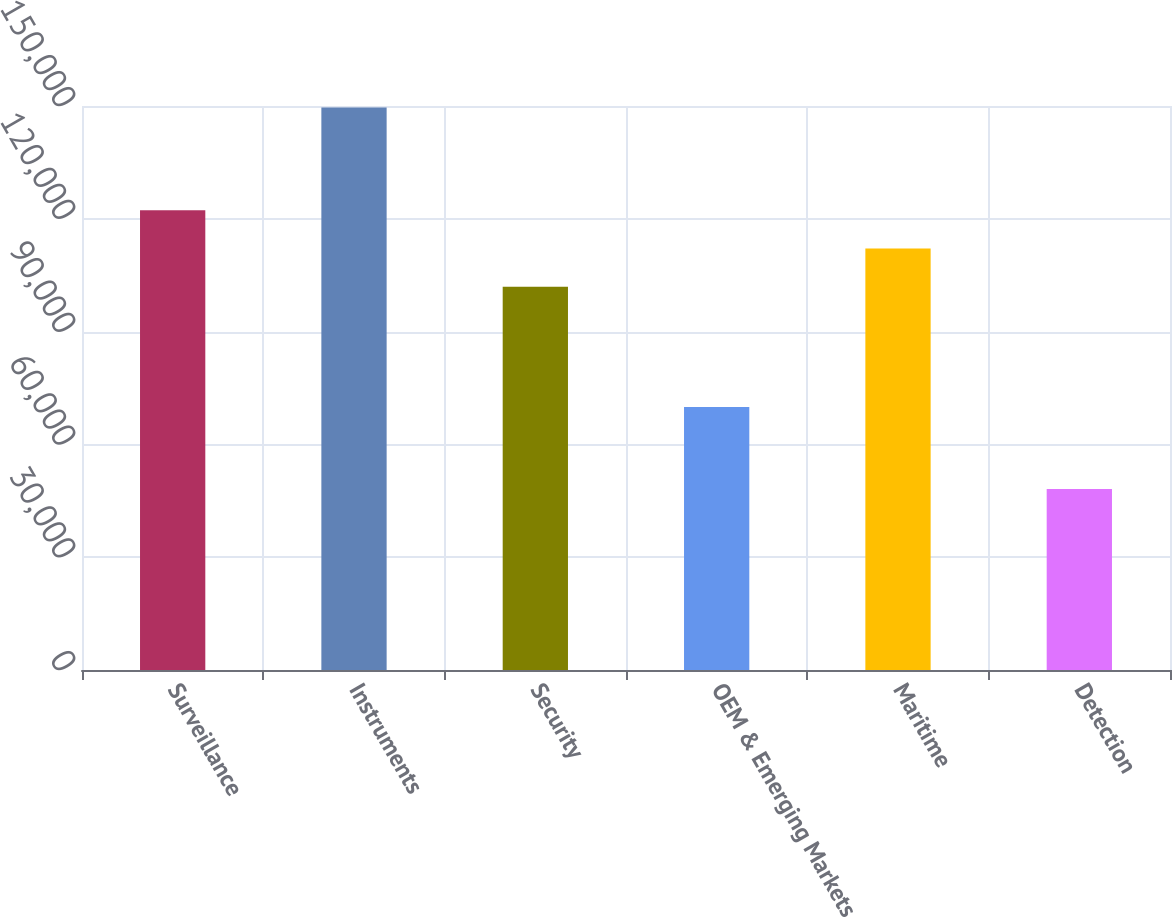Convert chart. <chart><loc_0><loc_0><loc_500><loc_500><bar_chart><fcel>Surveillance<fcel>Instruments<fcel>Security<fcel>OEM & Emerging Markets<fcel>Maritime<fcel>Detection<nl><fcel>122249<fcel>149582<fcel>101955<fcel>69973<fcel>112102<fcel>48112<nl></chart> 